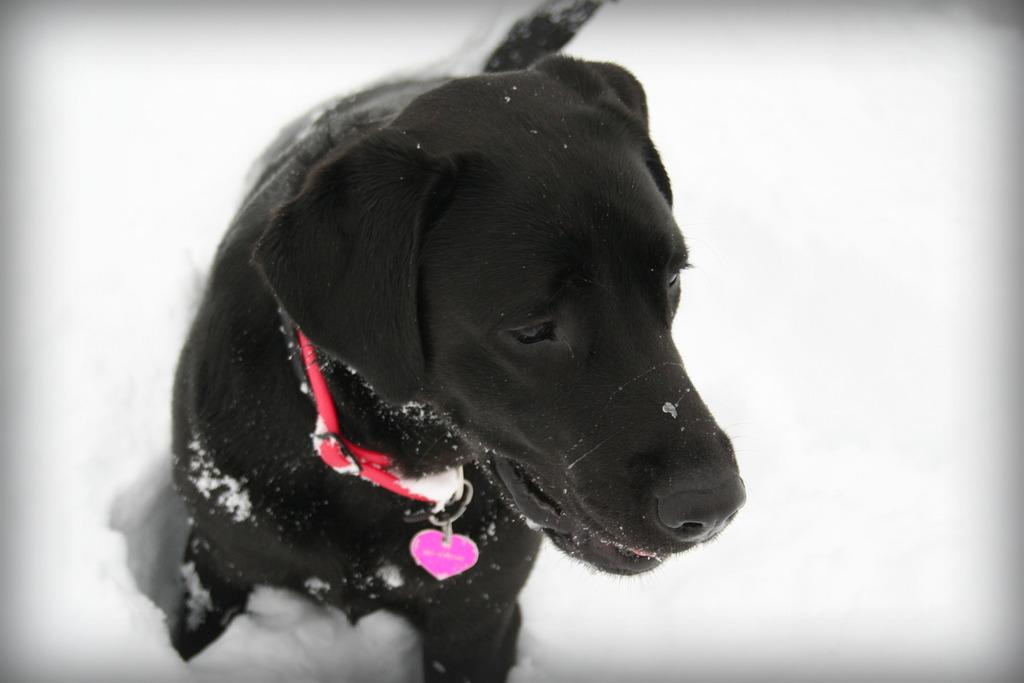What type of animal is present in the image? There is a black color dog in the image. What is the ground made of in the image? There is snow at the bottom of the image. What flavor of ice cream does the dog prefer in the image? There is no information about the dog's ice cream preferences in the image. 